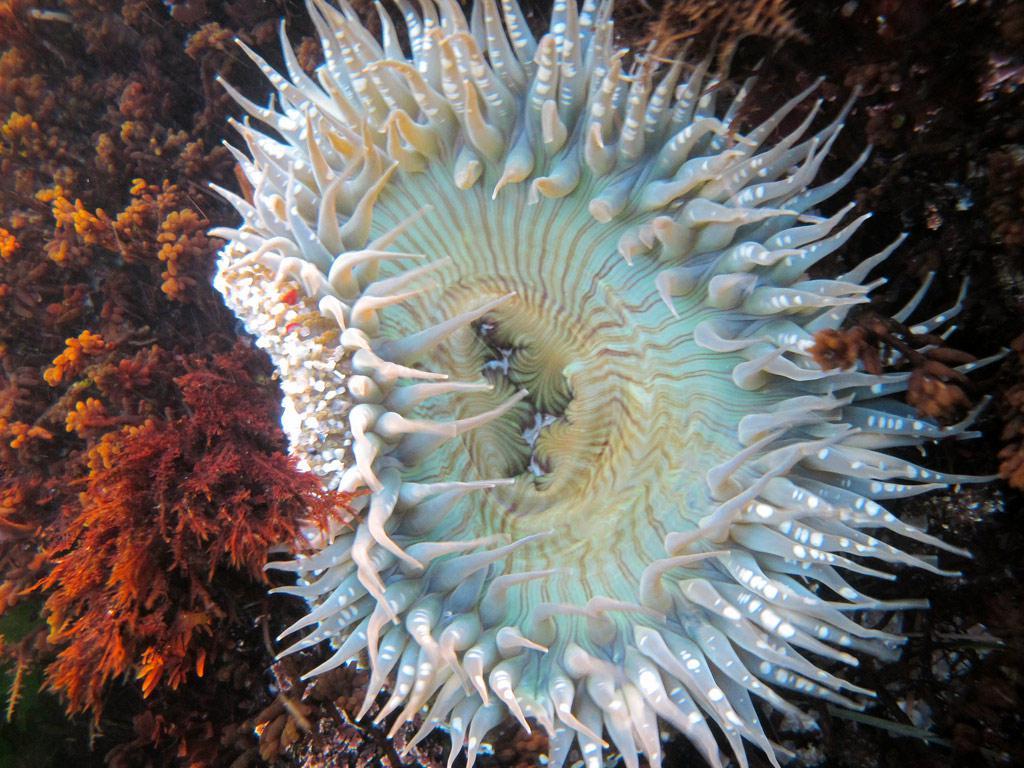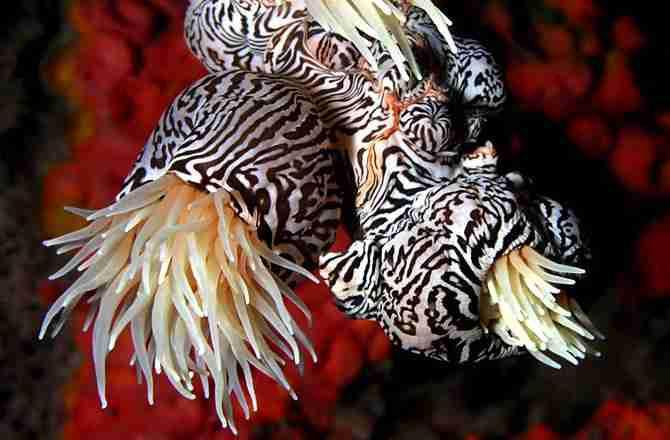The first image is the image on the left, the second image is the image on the right. For the images shown, is this caption "fish are swimming near anemones" true? Answer yes or no. No. The first image is the image on the left, the second image is the image on the right. Analyze the images presented: Is the assertion "White striped fish swim among anemones." valid? Answer yes or no. No. 